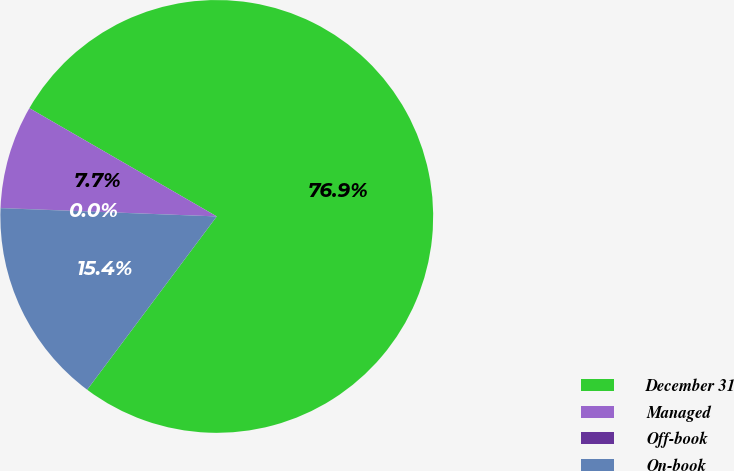Convert chart to OTSL. <chart><loc_0><loc_0><loc_500><loc_500><pie_chart><fcel>December 31<fcel>Managed<fcel>Off-book<fcel>On-book<nl><fcel>76.88%<fcel>7.71%<fcel>0.02%<fcel>15.39%<nl></chart> 